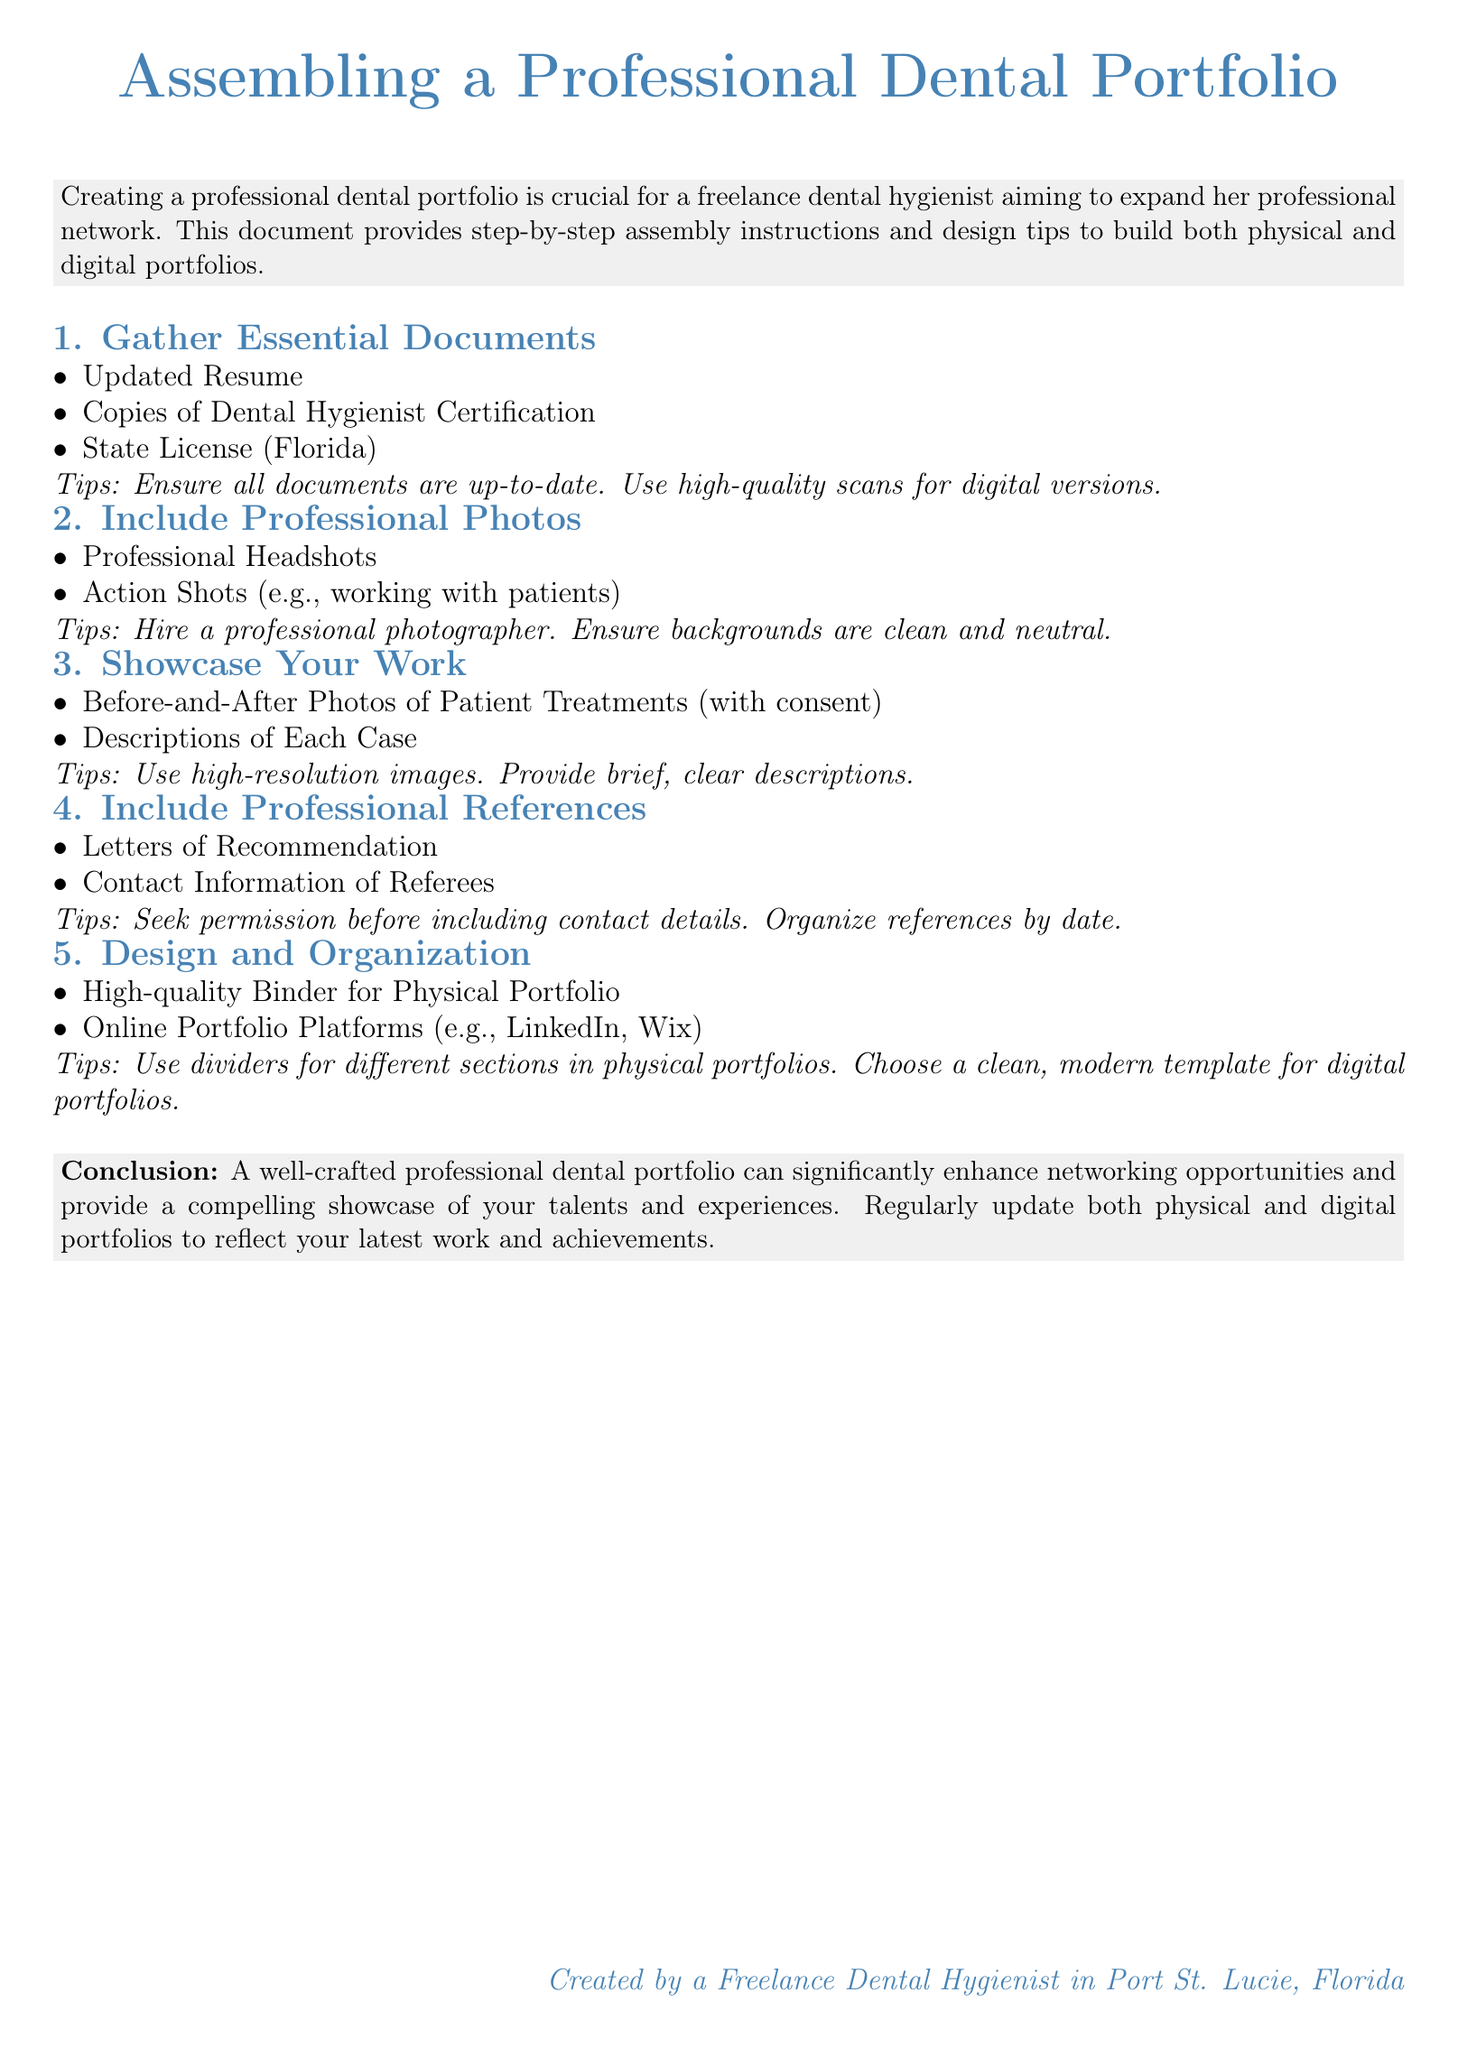What is the title of the document? The title of the document is prominently displayed at the top, indicating the primary subject covered.
Answer: Assembling a Professional Dental Portfolio What is included in the essential documents section? This section specifies the critical documents needed for the portfolio, focusing on professional credentials.
Answer: Updated Resume, Copies of Dental Hygienist Certification, State License (Florida) How many steps are provided in the assembly instructions? The document outlines a total number of specific steps required to create the portfolio effectively.
Answer: 5 What type of photos should be included in the portfolio? The document lists the kinds of imagery that will enhance the visual appeal and professionalism of the portfolio.
Answer: Professional Headshots, Action Shots What is a suggested platform for an online portfolio? The document recommends specific digital platforms where a portfolio can be showcased.
Answer: LinkedIn, Wix Why is seeking permission important before including references? This highlights a crucial ethical aspect regarding reference management in professional documentation.
Answer: Permission What design tip is given for organizing physical portfolios? This advice helps maintain clarity and ease of navigation within the physical representation of the portfolio.
Answer: Use dividers for different sections What does a well-crafted professional dental portfolio enhance? The document summarizes the impact of a well-prepared portfolio on professional interactions.
Answer: Networking opportunities 